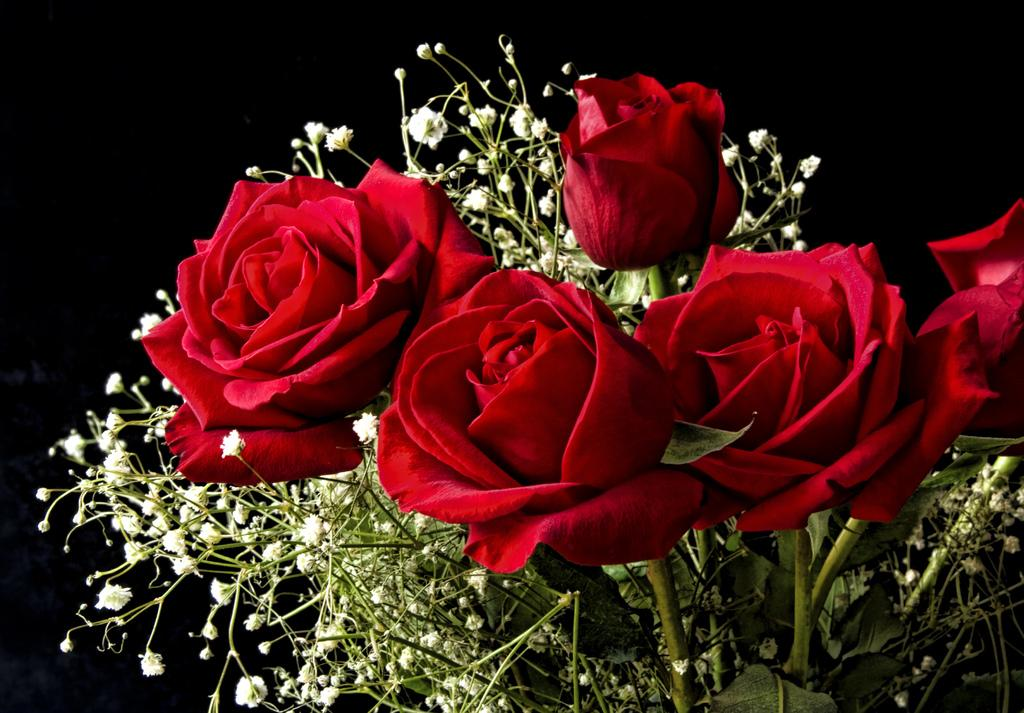What type of flowers are in the image? There are red roses and tiny flowers in the image. Can you describe the background of the image? The background of the image is dark. Where is the zoo located in the image? There is no zoo present in the image. What type of letters can be seen on the flowers in the image? There are no letters present on the flowers in the image. What mode of transportation can be seen in the image? There is no mode of transportation present in the image. 